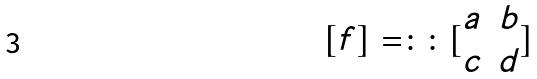<formula> <loc_0><loc_0><loc_500><loc_500>[ f ] = \colon \colon [ \begin{matrix} a & b \\ c & d \end{matrix} ]</formula> 